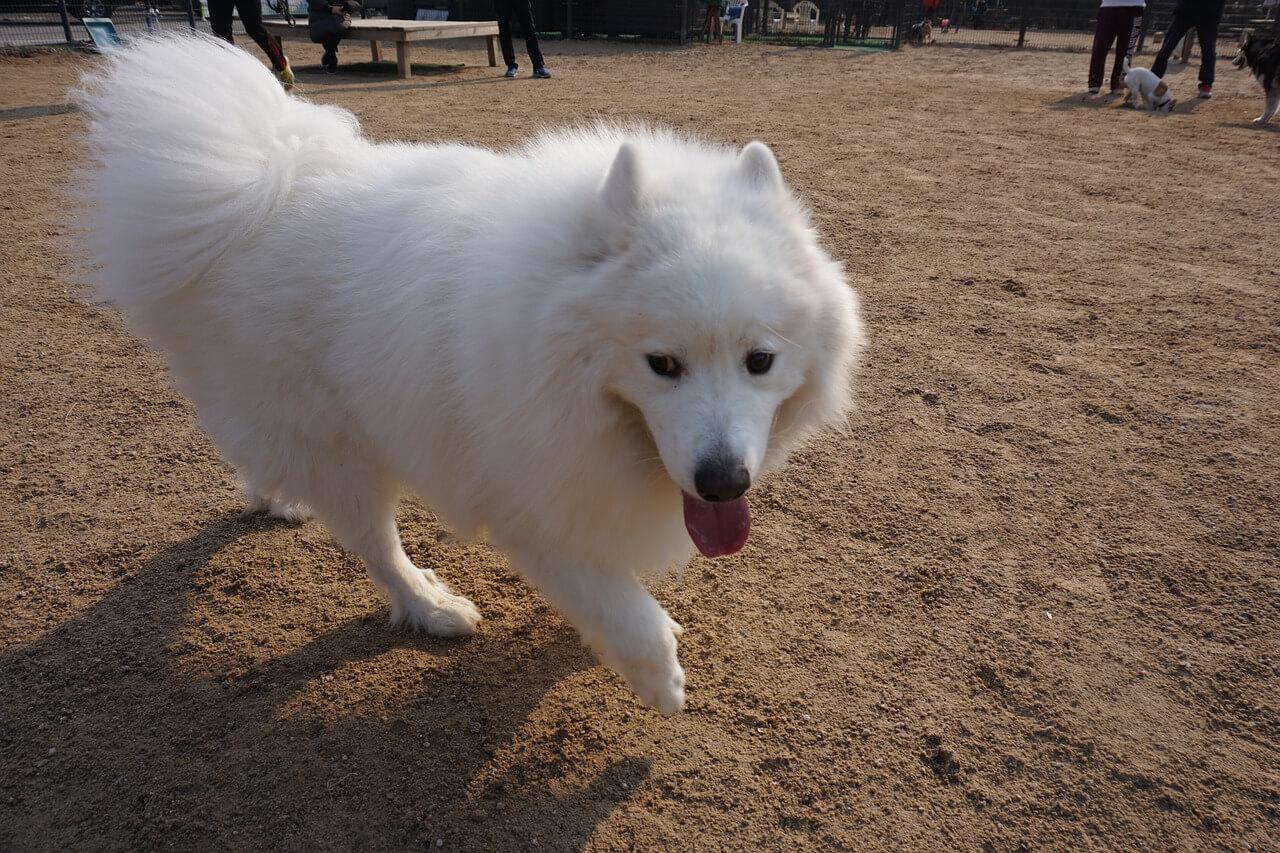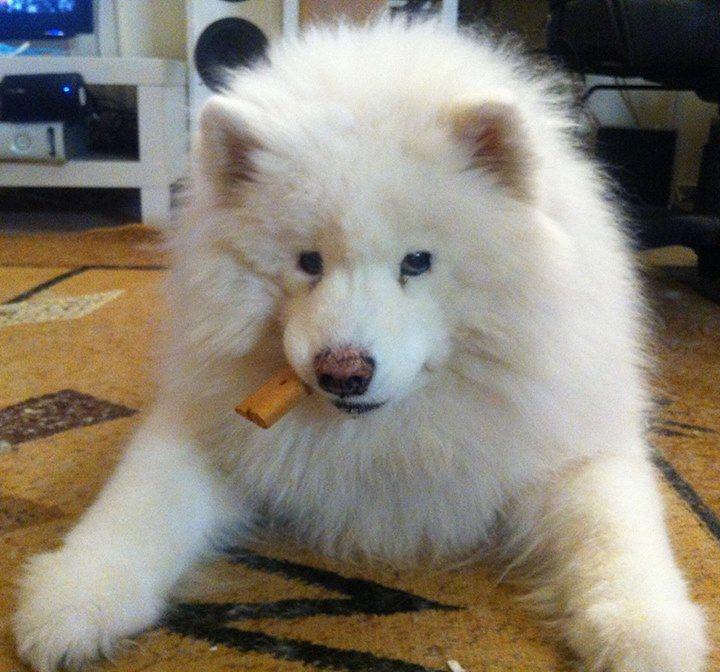The first image is the image on the left, the second image is the image on the right. For the images displayed, is the sentence "One image shows a reclining white dog chewing on something." factually correct? Answer yes or no. Yes. 